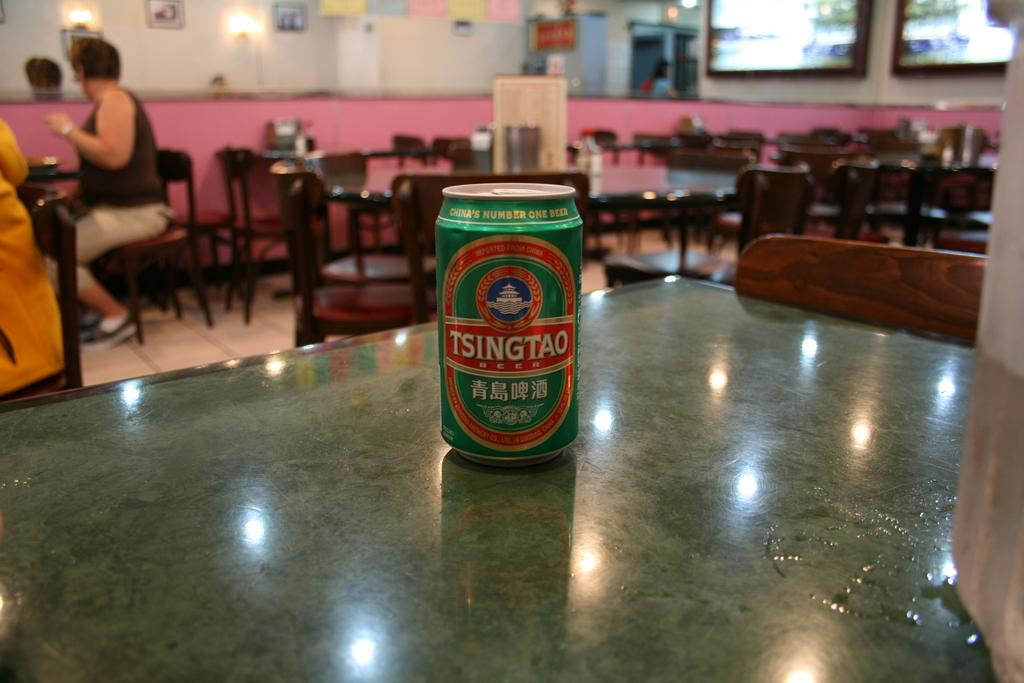<image>
Render a clear and concise summary of the photo. The tin sitting on a table in a cafe is of beer. 